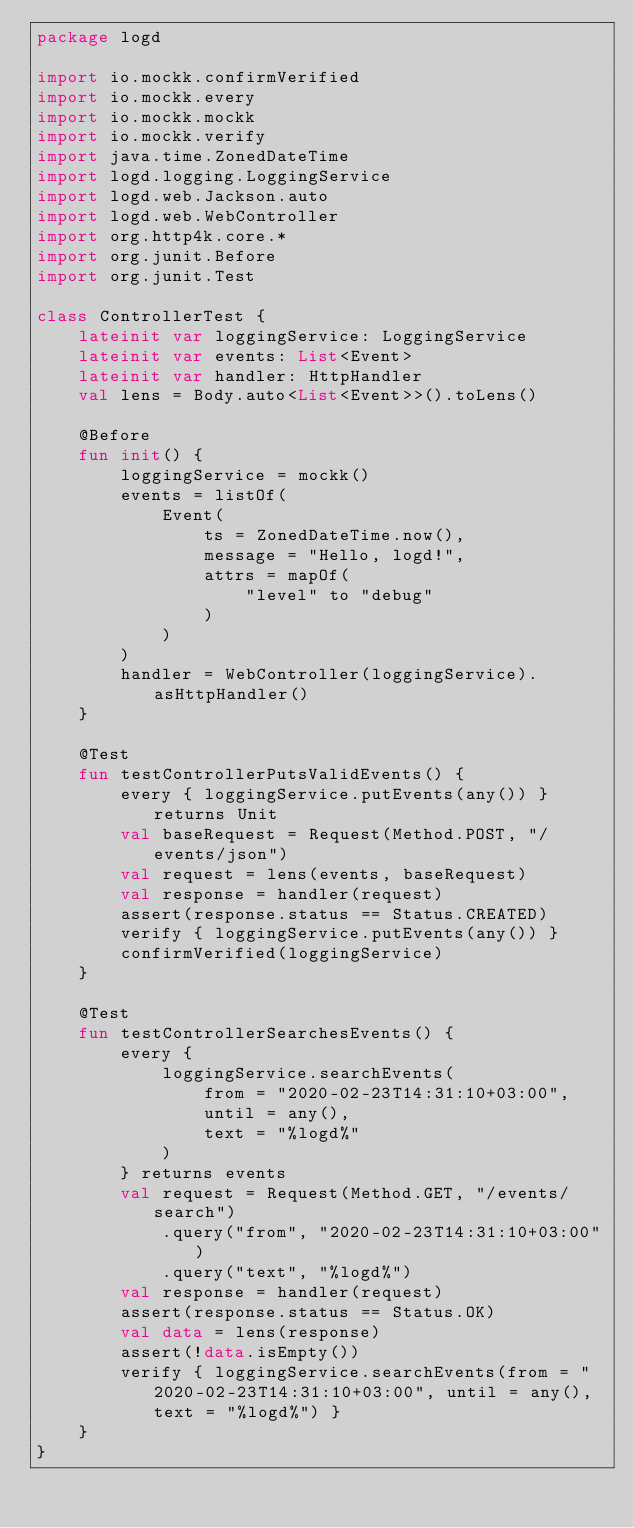Convert code to text. <code><loc_0><loc_0><loc_500><loc_500><_Kotlin_>package logd

import io.mockk.confirmVerified
import io.mockk.every
import io.mockk.mockk
import io.mockk.verify
import java.time.ZonedDateTime
import logd.logging.LoggingService
import logd.web.Jackson.auto
import logd.web.WebController
import org.http4k.core.*
import org.junit.Before
import org.junit.Test

class ControllerTest {
    lateinit var loggingService: LoggingService
    lateinit var events: List<Event>
    lateinit var handler: HttpHandler
    val lens = Body.auto<List<Event>>().toLens()

    @Before
    fun init() {
        loggingService = mockk()
        events = listOf(
            Event(
                ts = ZonedDateTime.now(),
                message = "Hello, logd!",
                attrs = mapOf(
                    "level" to "debug"
                )
            )
        )
        handler = WebController(loggingService).asHttpHandler()
    }

    @Test
    fun testControllerPutsValidEvents() {
        every { loggingService.putEvents(any()) } returns Unit
        val baseRequest = Request(Method.POST, "/events/json")
        val request = lens(events, baseRequest)
        val response = handler(request)
        assert(response.status == Status.CREATED)
        verify { loggingService.putEvents(any()) }
        confirmVerified(loggingService)
    }

    @Test
    fun testControllerSearchesEvents() {
        every {
            loggingService.searchEvents(
                from = "2020-02-23T14:31:10+03:00",
                until = any(),
                text = "%logd%"
            )
        } returns events
        val request = Request(Method.GET, "/events/search")
            .query("from", "2020-02-23T14:31:10+03:00")
            .query("text", "%logd%")
        val response = handler(request)
        assert(response.status == Status.OK)
        val data = lens(response)
        assert(!data.isEmpty())
        verify { loggingService.searchEvents(from = "2020-02-23T14:31:10+03:00", until = any(), text = "%logd%") }
    }
}
</code> 